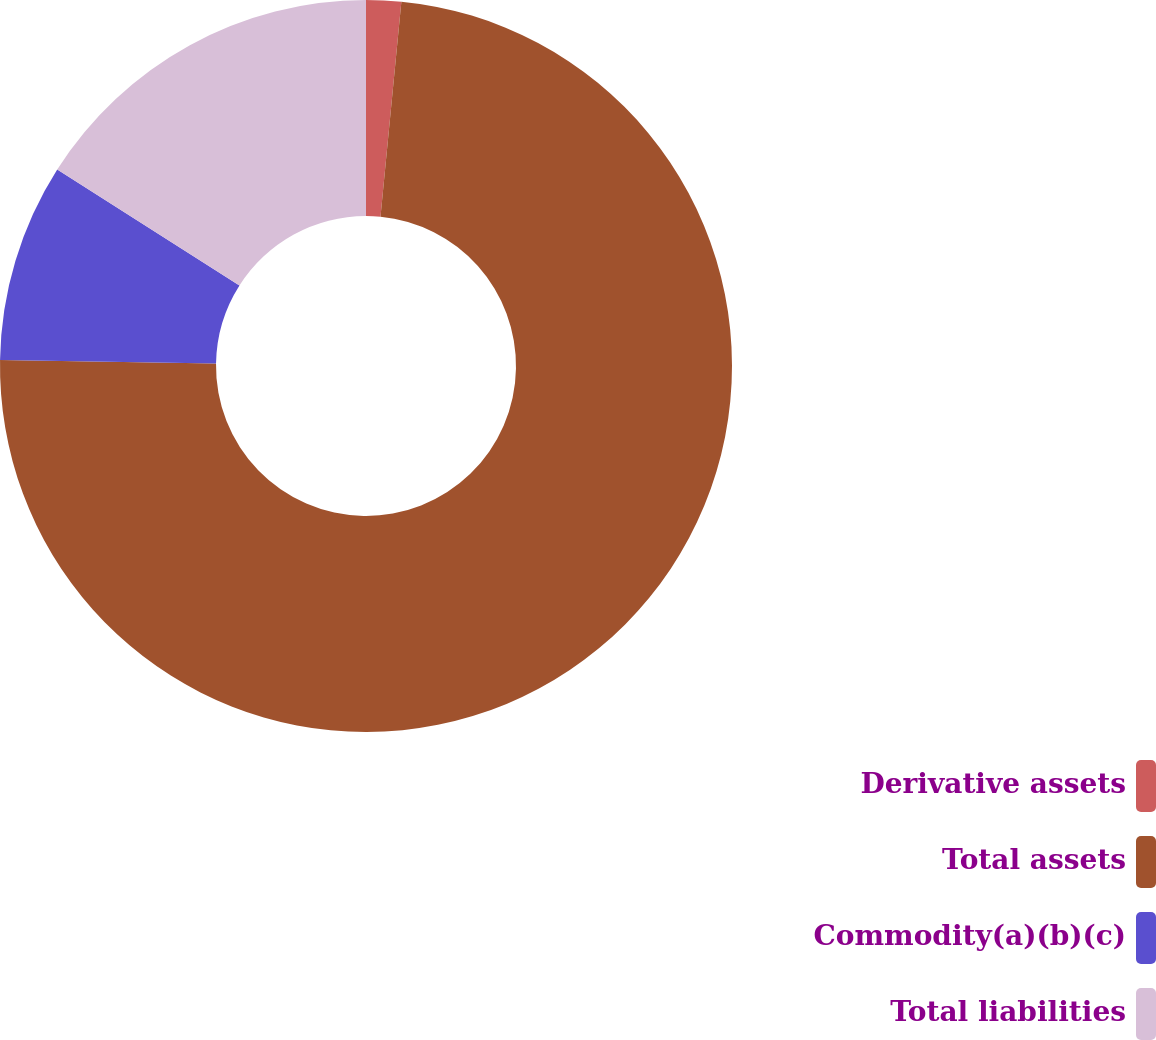Convert chart. <chart><loc_0><loc_0><loc_500><loc_500><pie_chart><fcel>Derivative assets<fcel>Total assets<fcel>Commodity(a)(b)(c)<fcel>Total liabilities<nl><fcel>1.54%<fcel>73.73%<fcel>8.76%<fcel>15.98%<nl></chart> 